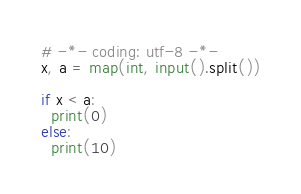<code> <loc_0><loc_0><loc_500><loc_500><_Python_># -*- coding: utf-8 -*-
x, a = map(int, input().split())

if x < a:
  print(0)
else:
  print(10)</code> 